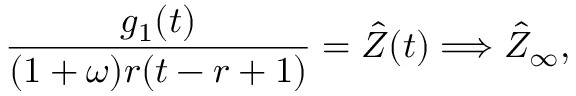<formula> <loc_0><loc_0><loc_500><loc_500>\frac { g _ { 1 } ( t ) } { ( 1 + \omega ) r ( t - r + 1 ) } = \hat { Z } ( t ) \Longrightarrow \hat { Z } _ { \infty } ,</formula> 